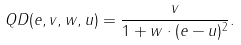<formula> <loc_0><loc_0><loc_500><loc_500>Q D ( e , v , w , u ) = \frac { v } { 1 + w \cdot ( e - u ) ^ { 2 } } .</formula> 